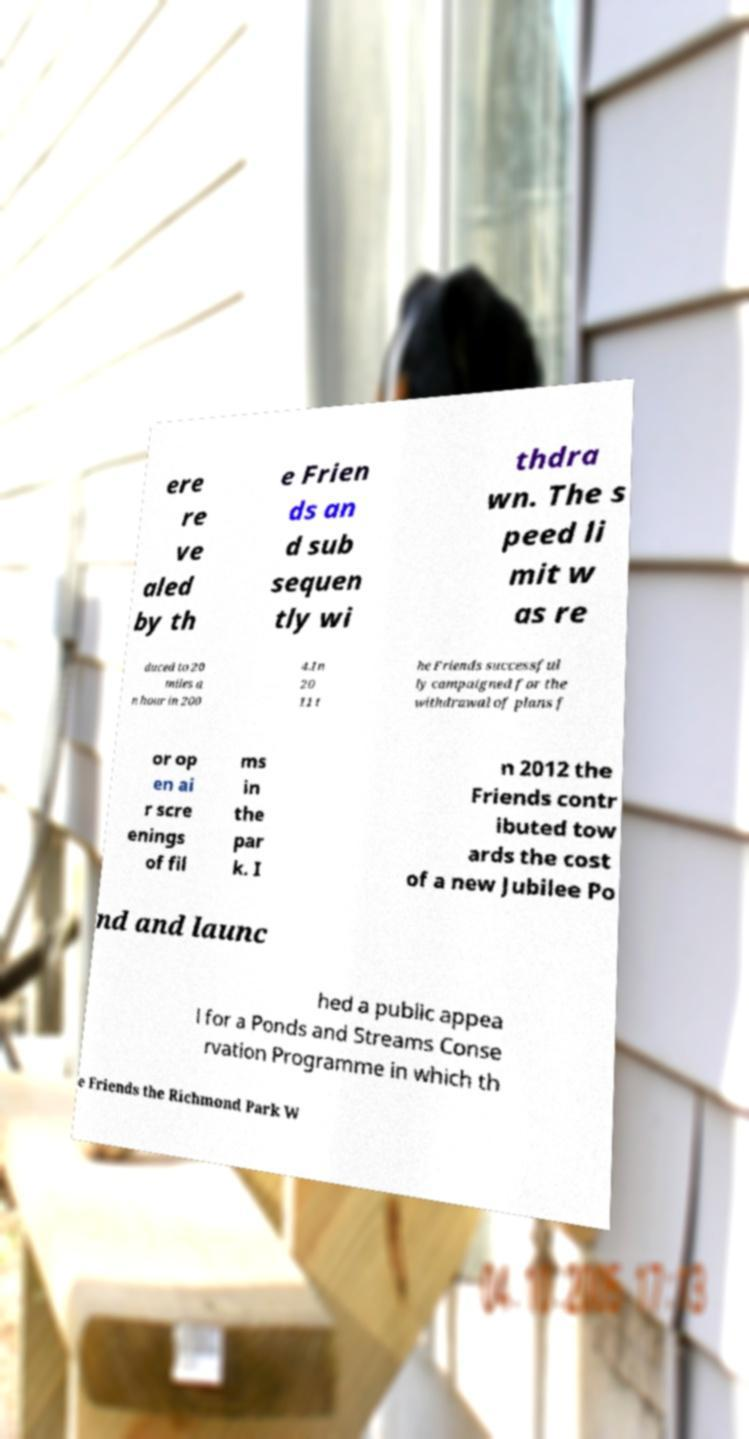Can you read and provide the text displayed in the image?This photo seems to have some interesting text. Can you extract and type it out for me? ere re ve aled by th e Frien ds an d sub sequen tly wi thdra wn. The s peed li mit w as re duced to 20 miles a n hour in 200 4.In 20 11 t he Friends successful ly campaigned for the withdrawal of plans f or op en ai r scre enings of fil ms in the par k. I n 2012 the Friends contr ibuted tow ards the cost of a new Jubilee Po nd and launc hed a public appea l for a Ponds and Streams Conse rvation Programme in which th e Friends the Richmond Park W 